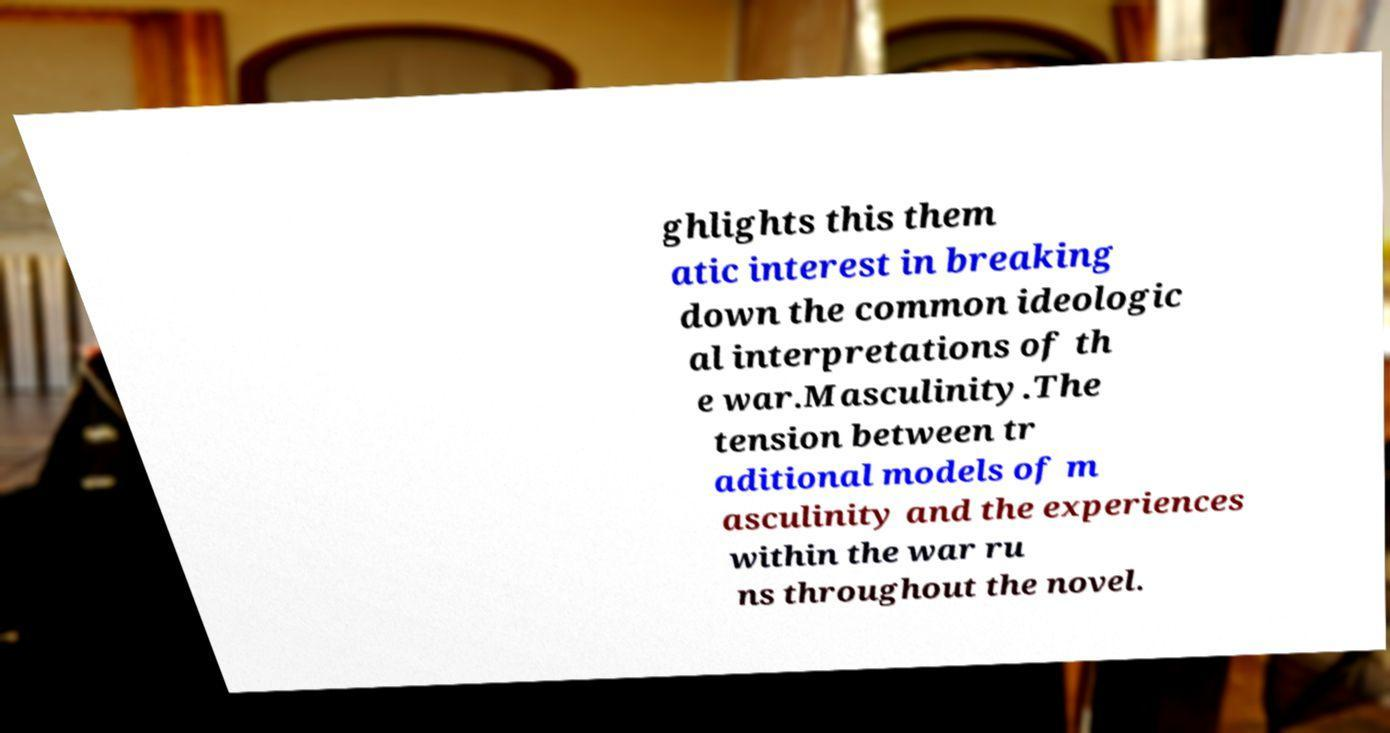What messages or text are displayed in this image? I need them in a readable, typed format. ghlights this them atic interest in breaking down the common ideologic al interpretations of th e war.Masculinity.The tension between tr aditional models of m asculinity and the experiences within the war ru ns throughout the novel. 